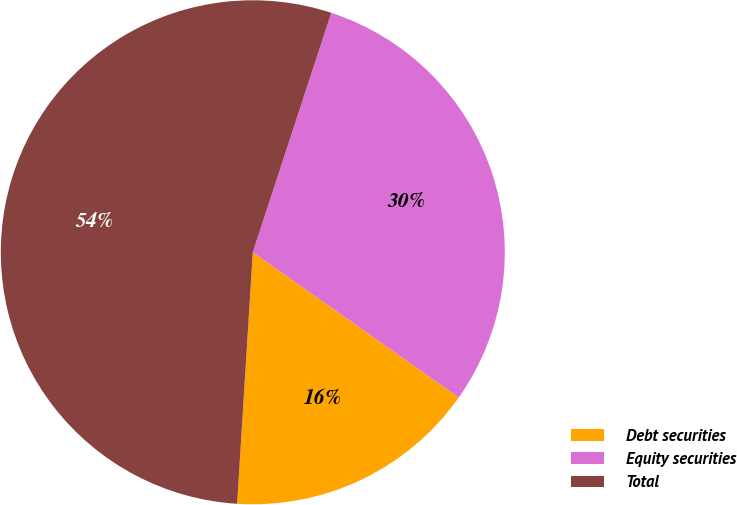Convert chart to OTSL. <chart><loc_0><loc_0><loc_500><loc_500><pie_chart><fcel>Debt securities<fcel>Equity securities<fcel>Total<nl><fcel>16.22%<fcel>29.73%<fcel>54.05%<nl></chart> 